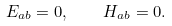<formula> <loc_0><loc_0><loc_500><loc_500>E _ { a b } = 0 , \quad H _ { a b } = 0 .</formula> 